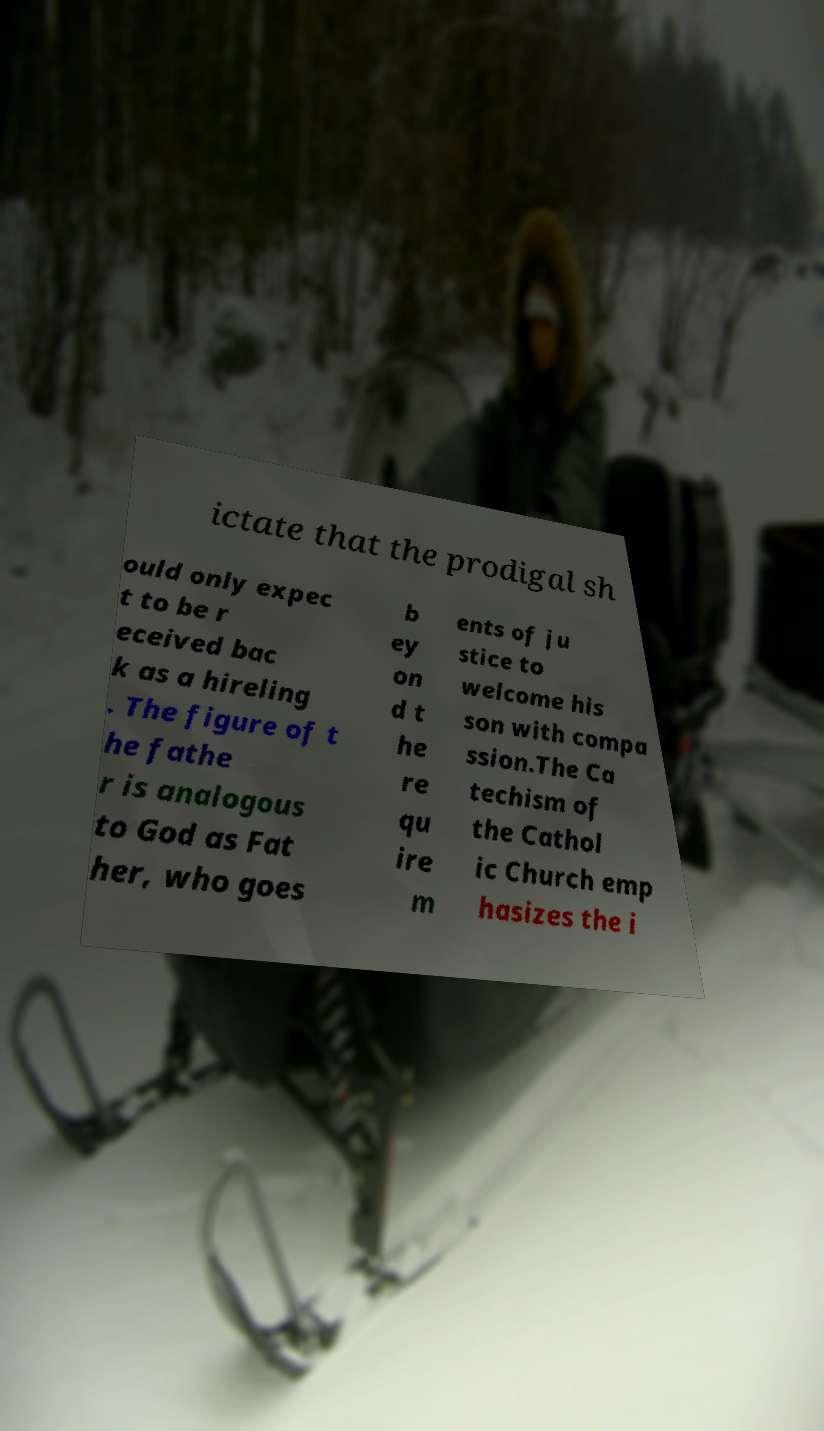Please identify and transcribe the text found in this image. ictate that the prodigal sh ould only expec t to be r eceived bac k as a hireling . The figure of t he fathe r is analogous to God as Fat her, who goes b ey on d t he re qu ire m ents of ju stice to welcome his son with compa ssion.The Ca techism of the Cathol ic Church emp hasizes the i 